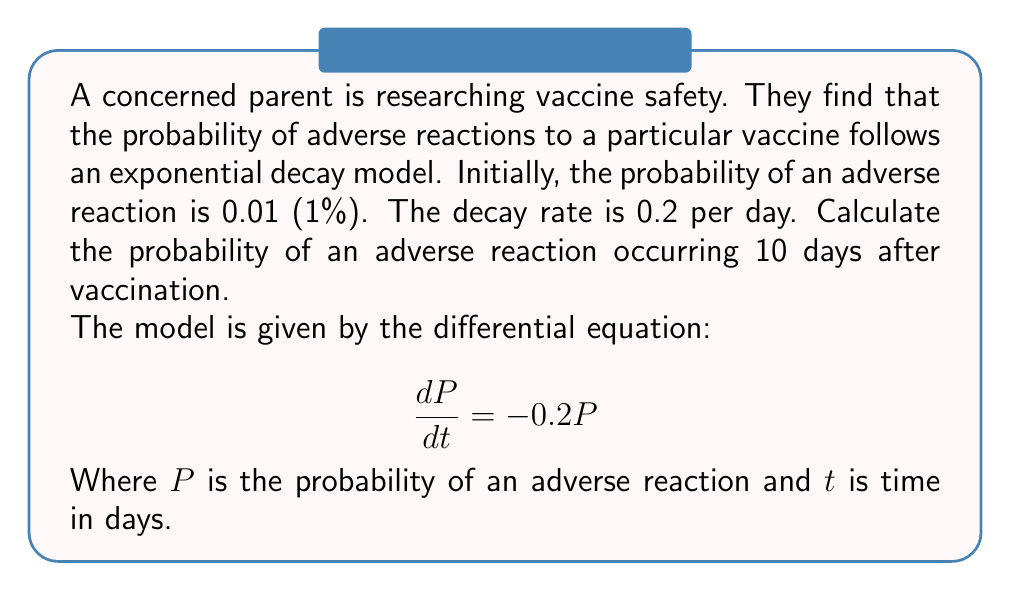Provide a solution to this math problem. Let's solve this step-by-step:

1) The general solution for this first-order differential equation is:
   $$P(t) = Ce^{-0.2t}$$
   where $C$ is a constant we need to determine.

2) We know the initial condition: when $t=0$, $P(0) = 0.01$
   Substituting this into our general solution:
   $$0.01 = Ce^{-0.2(0)} = C$$

3) So our specific solution is:
   $$P(t) = 0.01e^{-0.2t}$$

4) Now, we want to find $P(10)$:
   $$P(10) = 0.01e^{-0.2(10)}$$

5) Calculate:
   $$P(10) = 0.01e^{-2} \approx 0.01 \times 0.1353 \approx 0.001353$$

6) Convert to a percentage:
   $$0.001353 \times 100\% \approx 0.1353\%$$
Answer: 0.1353% 